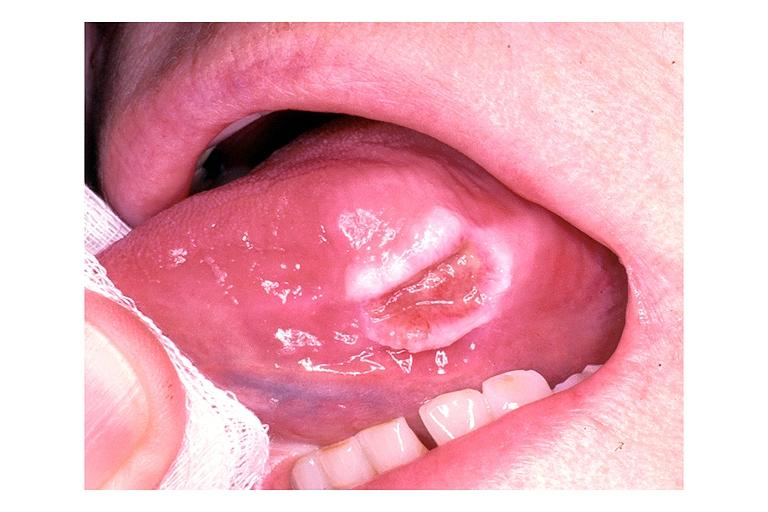what is present?
Answer the question using a single word or phrase. Oral 